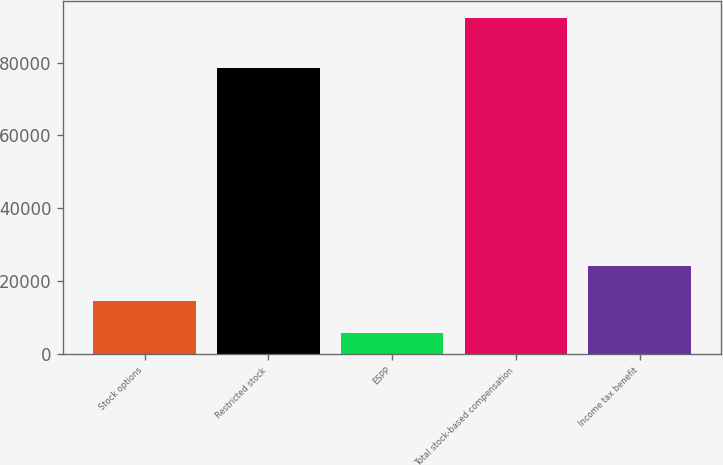Convert chart to OTSL. <chart><loc_0><loc_0><loc_500><loc_500><bar_chart><fcel>Stock options<fcel>Restricted stock<fcel>ESPP<fcel>Total stock-based compensation<fcel>Income tax benefit<nl><fcel>14474.8<fcel>78615<fcel>5823<fcel>92341<fcel>24294<nl></chart> 